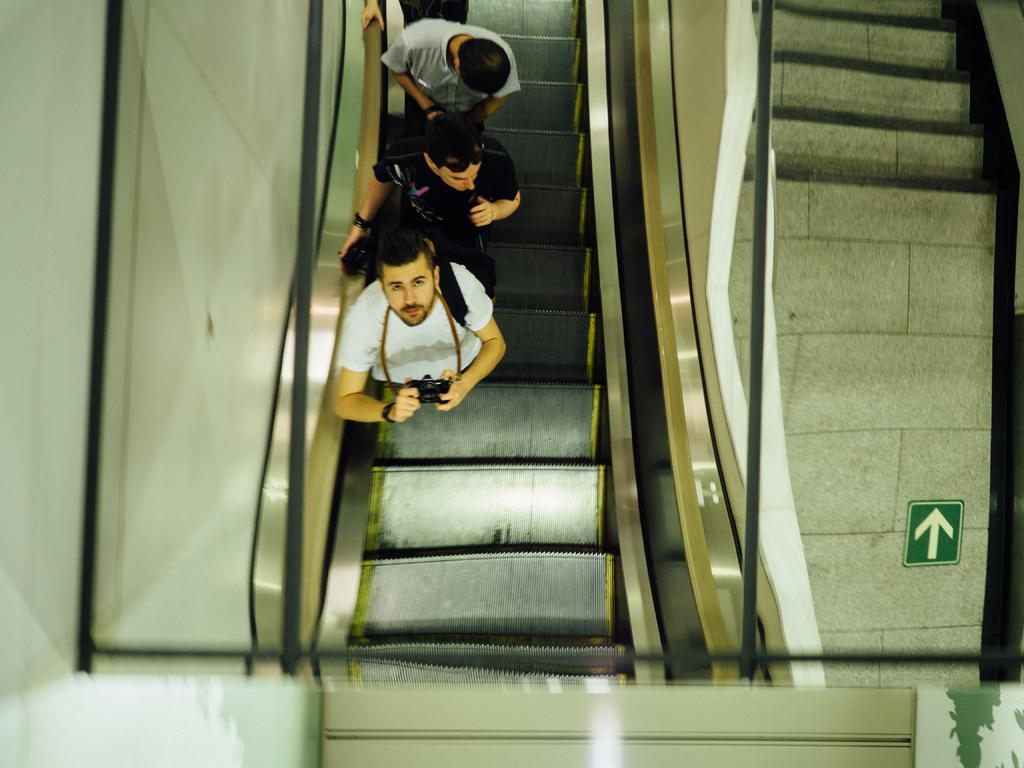How many people are in the image? There are three people in the image. What is the first person holding? The first person is holding a camera. Where is the first person standing? The first person is standing on a staircase of a lift. What type of island can be seen in the background of the image? There is no island visible in the image; it features three people and a person holding a camera on a staircase of a lift. 